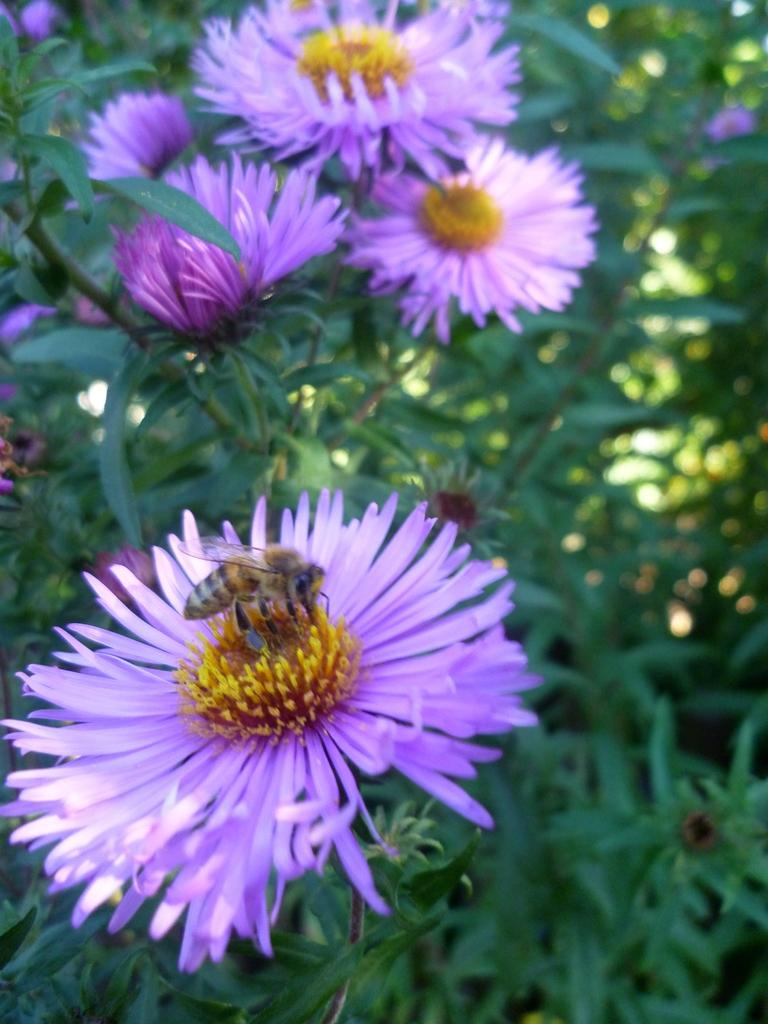What type of living organisms can be seen in the image? There are flowers and plants visible in the image. Can you describe any specific interactions happening in the image? Yes, there is a honey bee on one of the flowers. What might the honey bee be doing on the flower? The honey bee might be collecting nectar or pollen from the flower. What type of jam can be seen on the wire in the image? There is no jam or wire present in the image; it features flowers, plants, and a honey bee. 